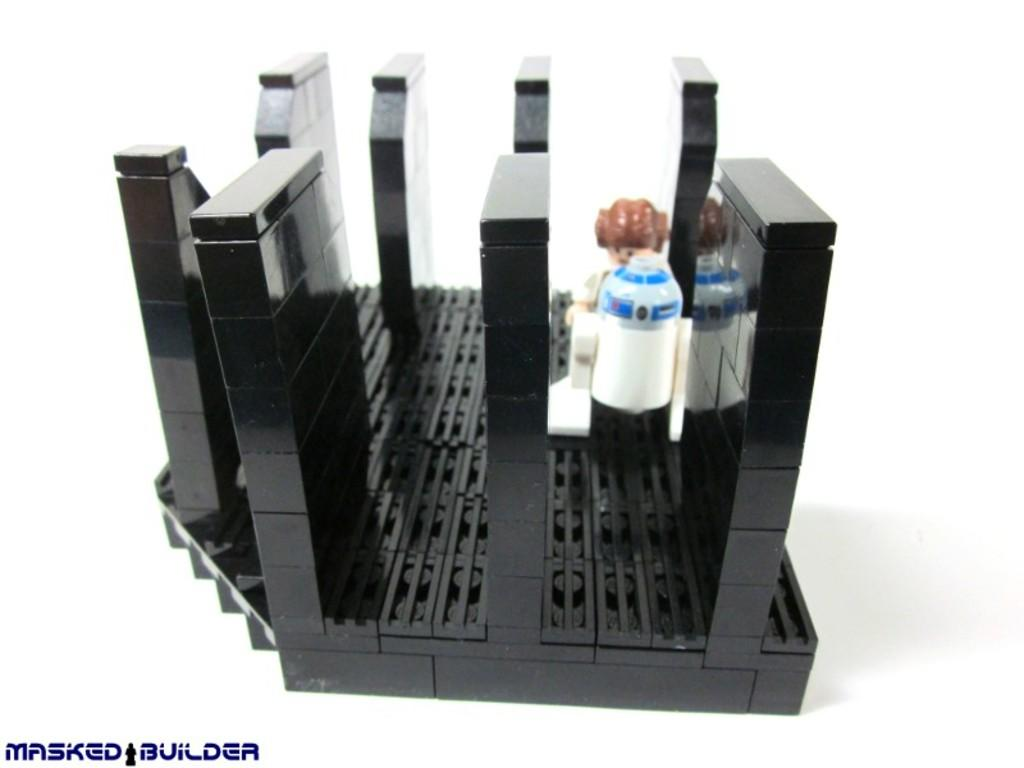Provide a one-sentence caption for the provided image. BLack legos with two figures from star wars by Masked builders. 